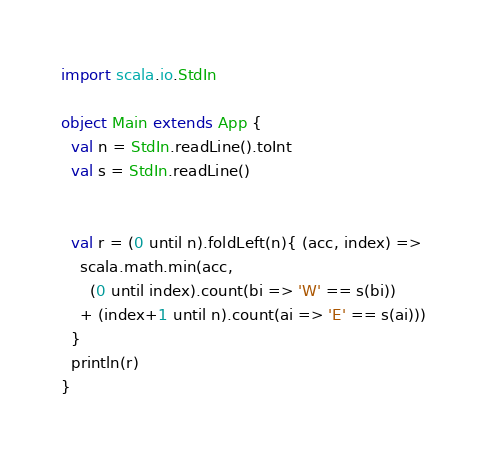Convert code to text. <code><loc_0><loc_0><loc_500><loc_500><_Scala_>import scala.io.StdIn

object Main extends App {
  val n = StdIn.readLine().toInt
  val s = StdIn.readLine()

  
  val r = (0 until n).foldLeft(n){ (acc, index) =>
    scala.math.min(acc, 
      (0 until index).count(bi => 'W' == s(bi))
    + (index+1 until n).count(ai => 'E' == s(ai)))
  }
  println(r)
}
</code> 